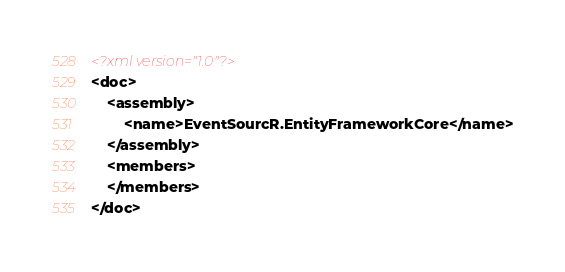<code> <loc_0><loc_0><loc_500><loc_500><_XML_><?xml version="1.0"?>
<doc>
    <assembly>
        <name>EventSourcR.EntityFrameworkCore</name>
    </assembly>
    <members>
    </members>
</doc>
</code> 